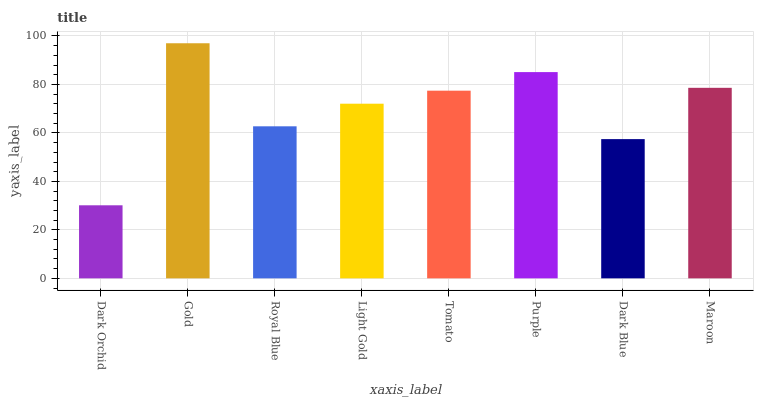Is Gold the maximum?
Answer yes or no. Yes. Is Royal Blue the minimum?
Answer yes or no. No. Is Royal Blue the maximum?
Answer yes or no. No. Is Gold greater than Royal Blue?
Answer yes or no. Yes. Is Royal Blue less than Gold?
Answer yes or no. Yes. Is Royal Blue greater than Gold?
Answer yes or no. No. Is Gold less than Royal Blue?
Answer yes or no. No. Is Tomato the high median?
Answer yes or no. Yes. Is Light Gold the low median?
Answer yes or no. Yes. Is Purple the high median?
Answer yes or no. No. Is Gold the low median?
Answer yes or no. No. 